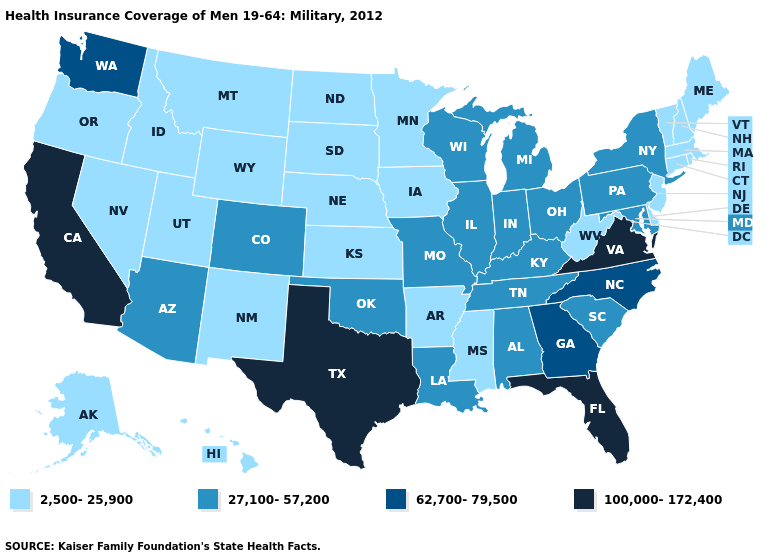Name the states that have a value in the range 62,700-79,500?
Concise answer only. Georgia, North Carolina, Washington. What is the highest value in the USA?
Short answer required. 100,000-172,400. Among the states that border Nebraska , which have the lowest value?
Short answer required. Iowa, Kansas, South Dakota, Wyoming. What is the value of New Hampshire?
Short answer required. 2,500-25,900. What is the highest value in the West ?
Keep it brief. 100,000-172,400. What is the value of Washington?
Be succinct. 62,700-79,500. What is the value of Virginia?
Give a very brief answer. 100,000-172,400. Among the states that border North Carolina , which have the highest value?
Give a very brief answer. Virginia. What is the value of Tennessee?
Keep it brief. 27,100-57,200. Name the states that have a value in the range 100,000-172,400?
Give a very brief answer. California, Florida, Texas, Virginia. Name the states that have a value in the range 27,100-57,200?
Short answer required. Alabama, Arizona, Colorado, Illinois, Indiana, Kentucky, Louisiana, Maryland, Michigan, Missouri, New York, Ohio, Oklahoma, Pennsylvania, South Carolina, Tennessee, Wisconsin. What is the lowest value in states that border Indiana?
Short answer required. 27,100-57,200. Name the states that have a value in the range 62,700-79,500?
Answer briefly. Georgia, North Carolina, Washington. What is the highest value in the Northeast ?
Concise answer only. 27,100-57,200. Among the states that border North Carolina , does Tennessee have the lowest value?
Give a very brief answer. Yes. 